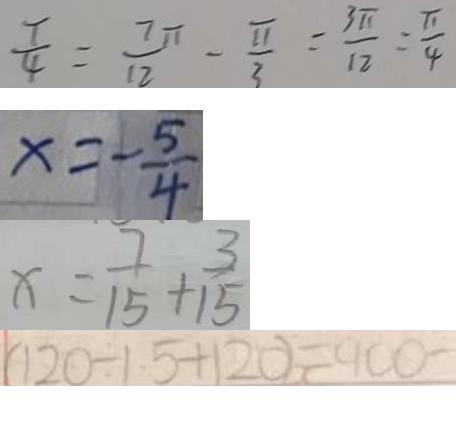Convert formula to latex. <formula><loc_0><loc_0><loc_500><loc_500>\frac { T } { 4 } = \frac { 7 \pi } { 1 2 } - \frac { \sqrt { \pi } } { 3 } = \frac { 3 \pi } { 1 2 } = \frac { \pi } { 4 } 
 x = - \frac { 5 } { 4 } 
 x = \frac { 7 } { 1 5 } + \frac { 3 } { 1 5 } 
 ( 1 2 0 \div 1 . 5 + 1 2 0 ) = 9 0 0 -</formula> 